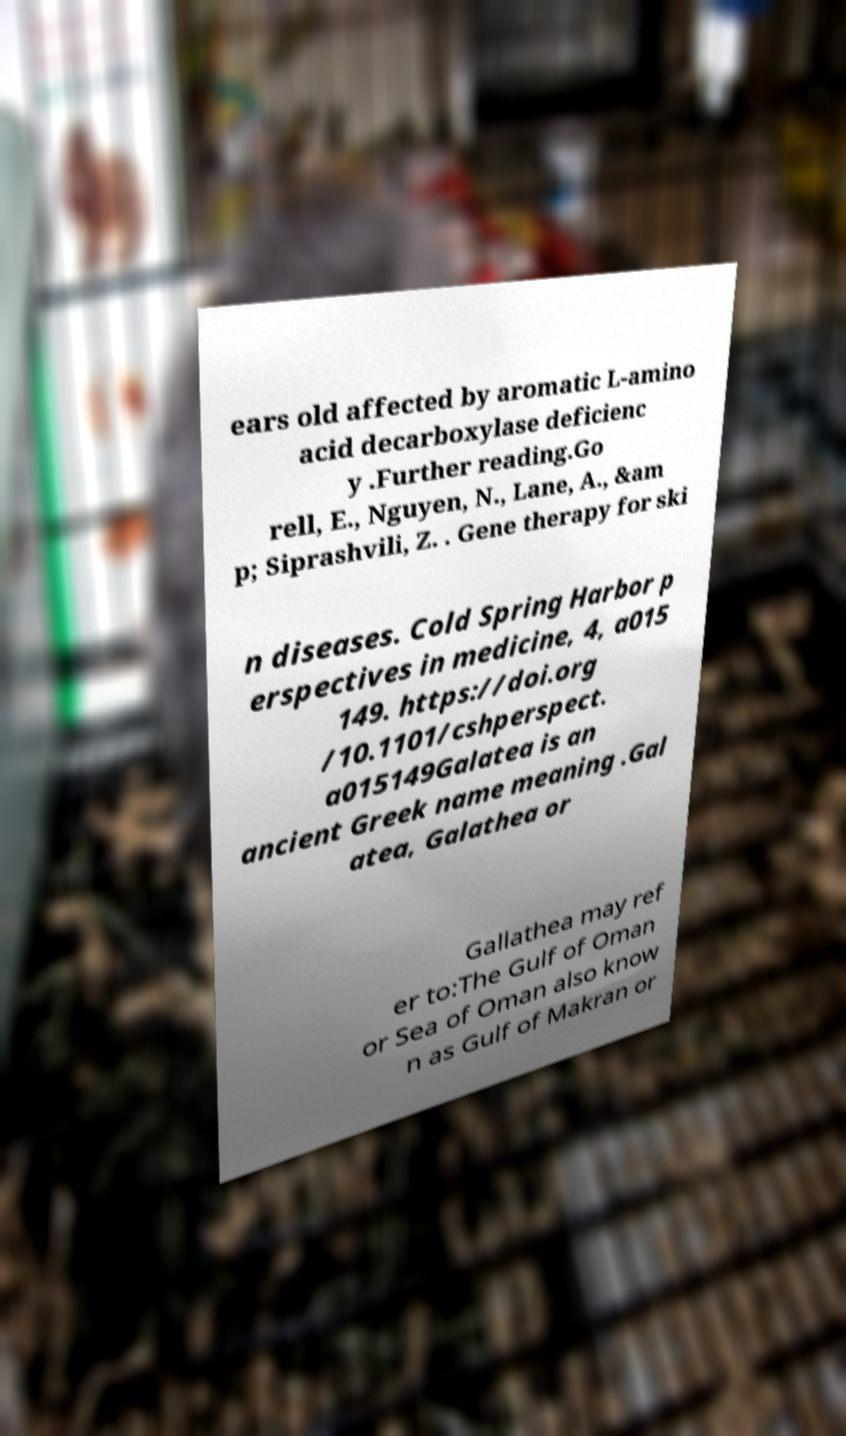Could you assist in decoding the text presented in this image and type it out clearly? ears old affected by aromatic L-amino acid decarboxylase deficienc y .Further reading.Go rell, E., Nguyen, N., Lane, A., &am p; Siprashvili, Z. . Gene therapy for ski n diseases. Cold Spring Harbor p erspectives in medicine, 4, a015 149. https://doi.org /10.1101/cshperspect. a015149Galatea is an ancient Greek name meaning .Gal atea, Galathea or Gallathea may ref er to:The Gulf of Oman or Sea of Oman also know n as Gulf of Makran or 